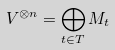Convert formula to latex. <formula><loc_0><loc_0><loc_500><loc_500>V ^ { \otimes n } = \bigoplus _ { t \in T } M _ { t }</formula> 